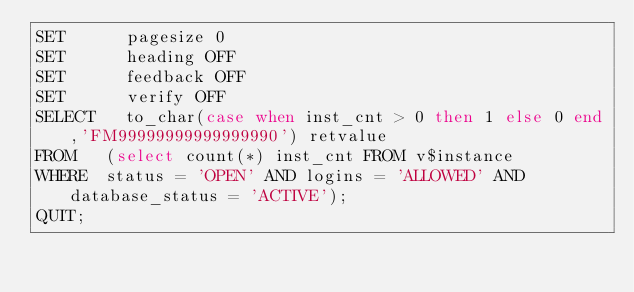Convert code to text. <code><loc_0><loc_0><loc_500><loc_500><_SQL_>SET      pagesize 0
SET      heading OFF
SET      feedback OFF
SET      verify OFF
SELECT	 to_char(case when inst_cnt > 0 then 1 else 0 end,'FM99999999999999990') retvalue
FROM	 (select count(*) inst_cnt FROM v$instance 
WHERE	 status = 'OPEN' AND logins = 'ALLOWED' AND database_status = 'ACTIVE');
QUIT;
</code> 